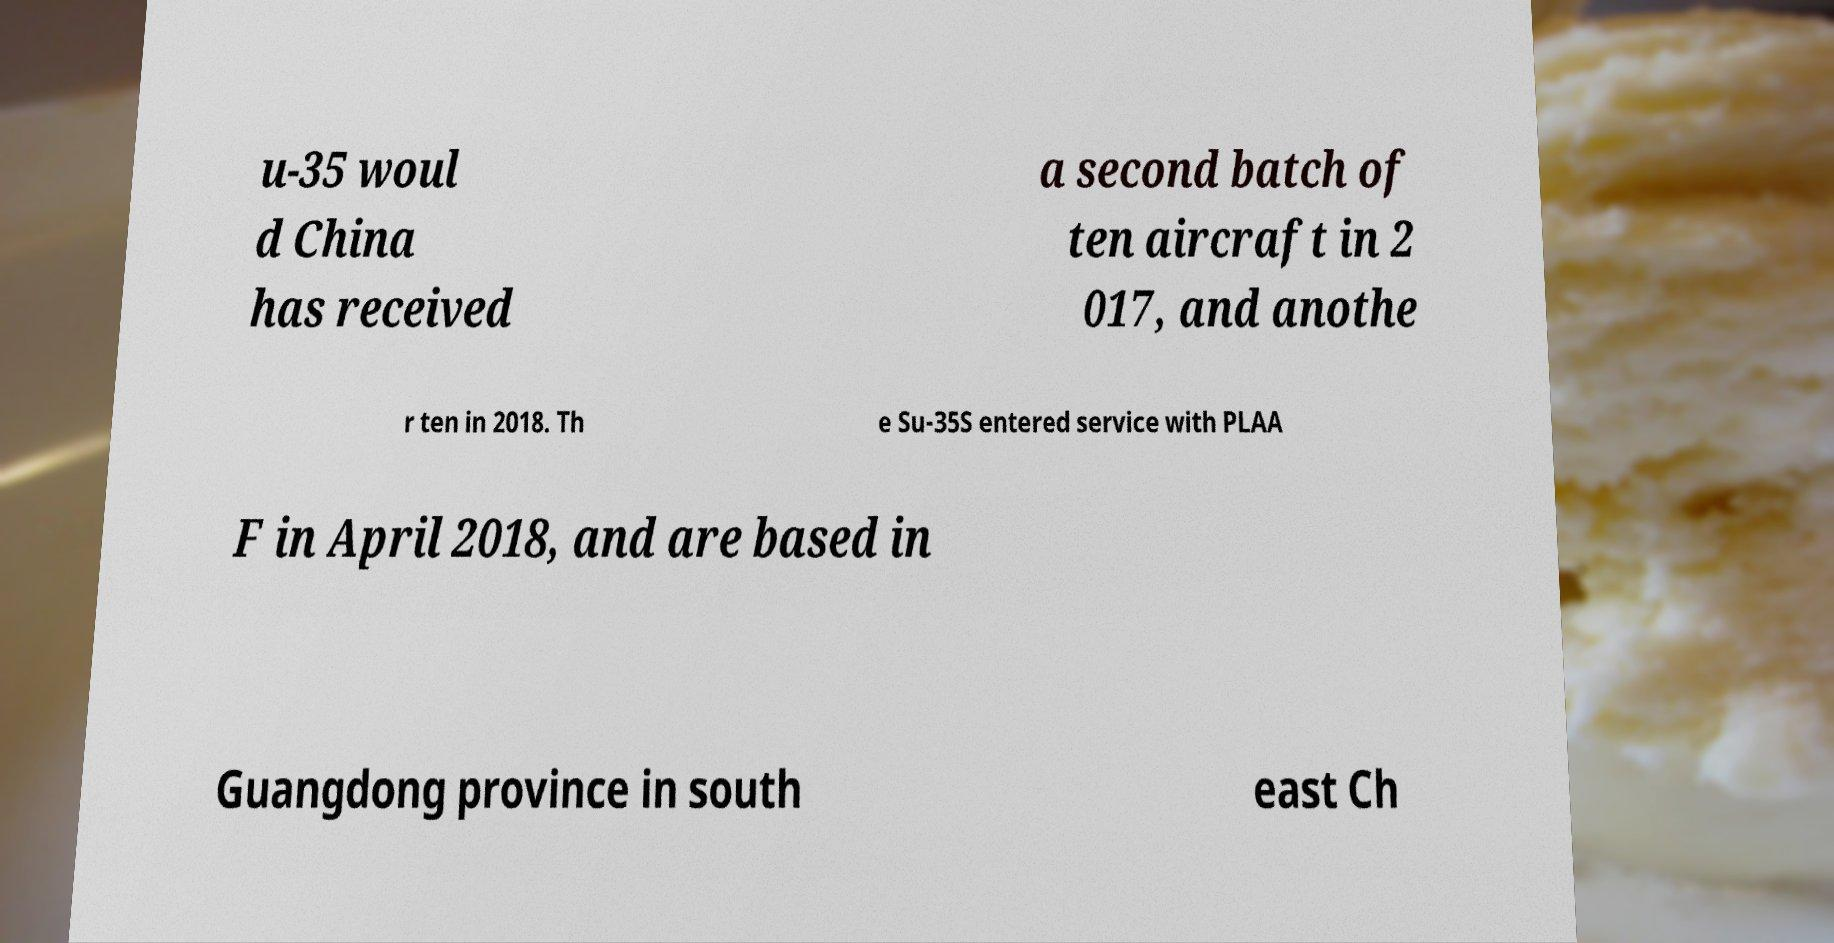For documentation purposes, I need the text within this image transcribed. Could you provide that? u-35 woul d China has received a second batch of ten aircraft in 2 017, and anothe r ten in 2018. Th e Su-35S entered service with PLAA F in April 2018, and are based in Guangdong province in south east Ch 